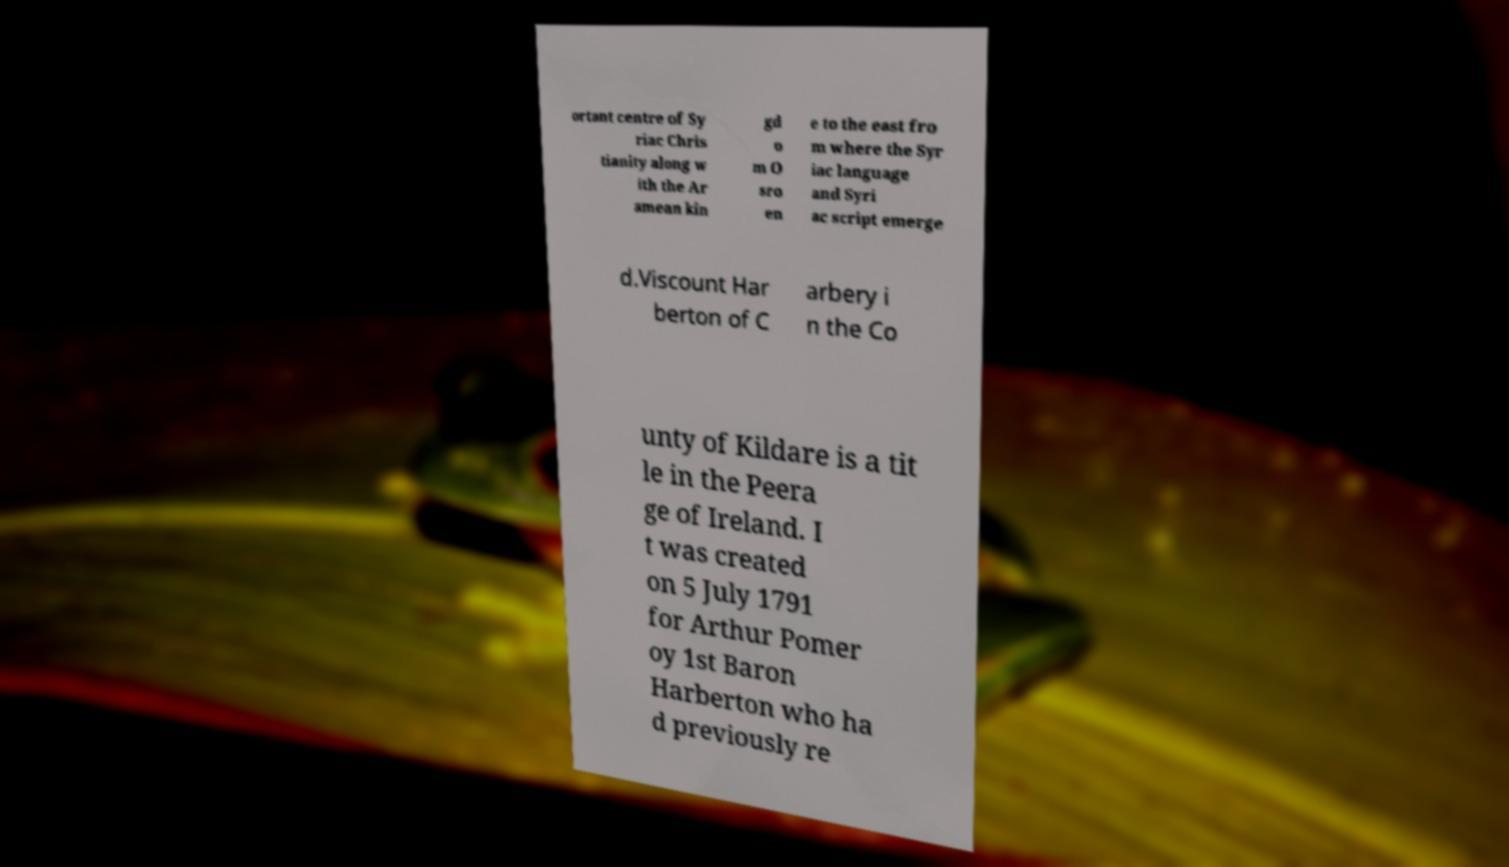Please read and relay the text visible in this image. What does it say? ortant centre of Sy riac Chris tianity along w ith the Ar amean kin gd o m O sro en e to the east fro m where the Syr iac language and Syri ac script emerge d.Viscount Har berton of C arbery i n the Co unty of Kildare is a tit le in the Peera ge of Ireland. I t was created on 5 July 1791 for Arthur Pomer oy 1st Baron Harberton who ha d previously re 